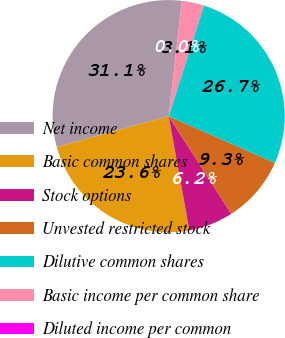Convert chart. <chart><loc_0><loc_0><loc_500><loc_500><pie_chart><fcel>Net income<fcel>Basic common shares<fcel>Stock options<fcel>Unvested restricted stock<fcel>Dilutive common shares<fcel>Basic income per common share<fcel>Diluted income per common<nl><fcel>31.1%<fcel>23.56%<fcel>6.22%<fcel>9.33%<fcel>26.67%<fcel>3.11%<fcel>0.0%<nl></chart> 